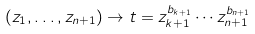<formula> <loc_0><loc_0><loc_500><loc_500>( z _ { 1 } , \dots , z _ { n + 1 } ) \to t = z _ { k + 1 } ^ { b _ { k + 1 } } \cdots z _ { n + 1 } ^ { b _ { n + 1 } }</formula> 